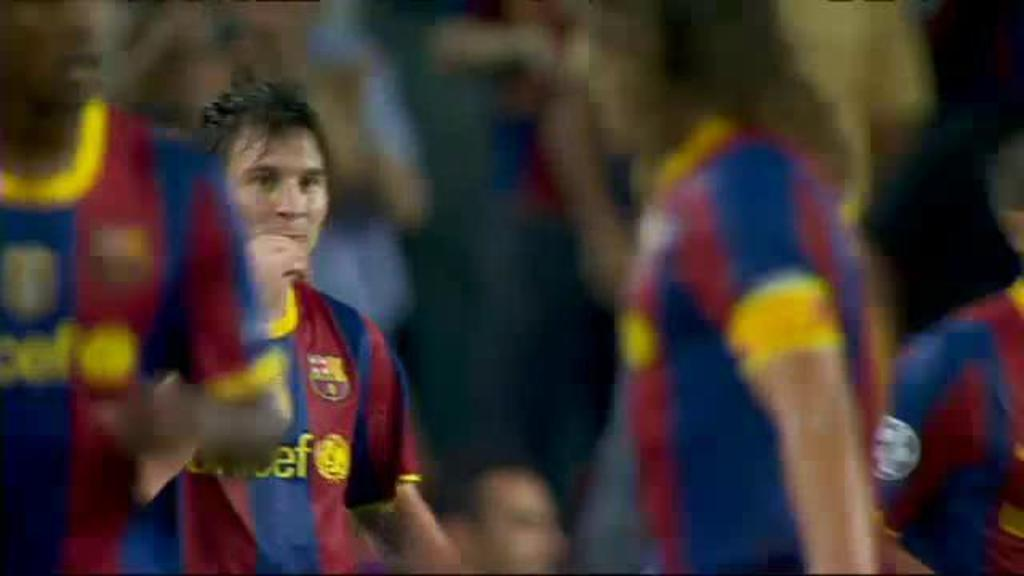What is the main subject of the image? The main subject of the image is many football players. What are the football players doing in the image? The football players are walking. Can you describe the background of the image? There are people standing in the background of the image. What is the purpose of the hall in the image? There is no hall present in the image; it features football players walking and people standing in the background. 